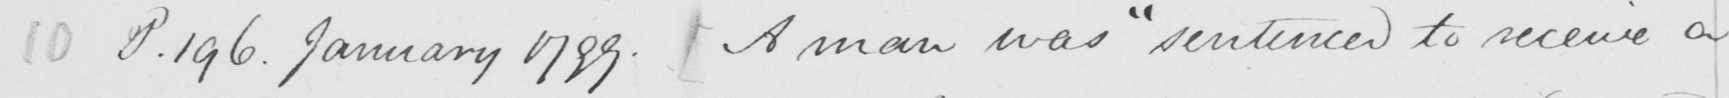What is written in this line of handwriting? 10 P.196 . January 1799 .  [  A man was  " sentenced to receive a 